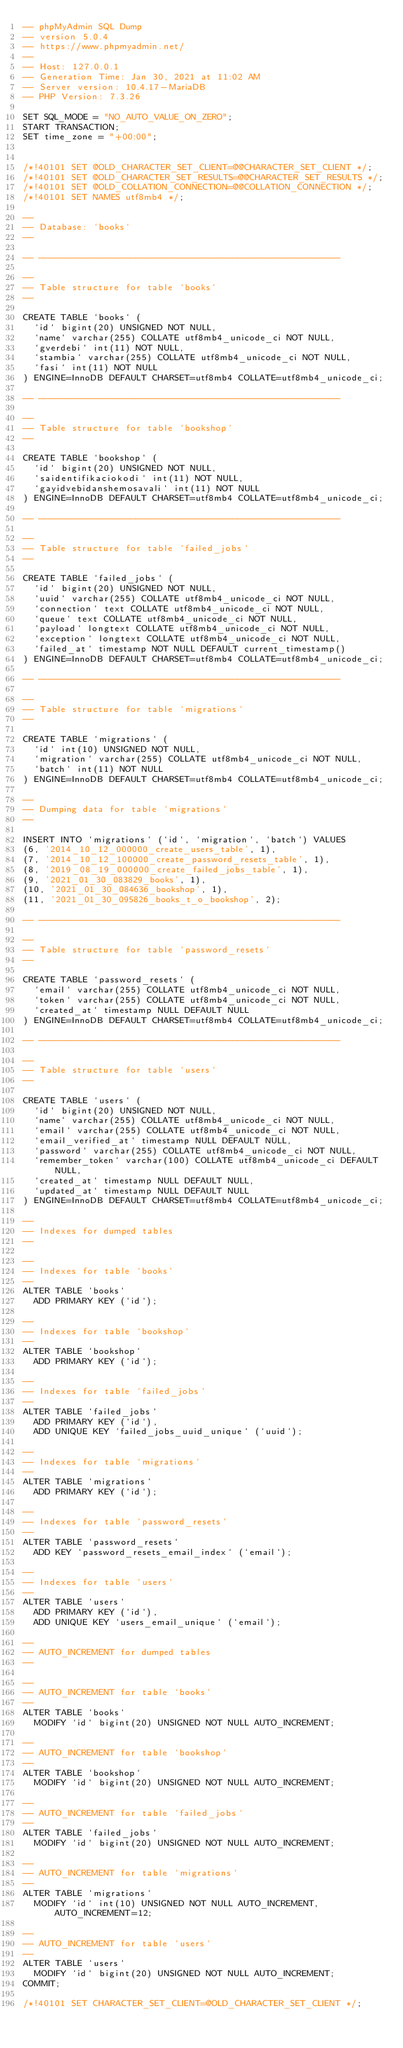Convert code to text. <code><loc_0><loc_0><loc_500><loc_500><_SQL_>-- phpMyAdmin SQL Dump
-- version 5.0.4
-- https://www.phpmyadmin.net/
--
-- Host: 127.0.0.1
-- Generation Time: Jan 30, 2021 at 11:02 AM
-- Server version: 10.4.17-MariaDB
-- PHP Version: 7.3.26

SET SQL_MODE = "NO_AUTO_VALUE_ON_ZERO";
START TRANSACTION;
SET time_zone = "+00:00";


/*!40101 SET @OLD_CHARACTER_SET_CLIENT=@@CHARACTER_SET_CLIENT */;
/*!40101 SET @OLD_CHARACTER_SET_RESULTS=@@CHARACTER_SET_RESULTS */;
/*!40101 SET @OLD_COLLATION_CONNECTION=@@COLLATION_CONNECTION */;
/*!40101 SET NAMES utf8mb4 */;

--
-- Database: `books`
--

-- --------------------------------------------------------

--
-- Table structure for table `books`
--

CREATE TABLE `books` (
  `id` bigint(20) UNSIGNED NOT NULL,
  `name` varchar(255) COLLATE utf8mb4_unicode_ci NOT NULL,
  `gverdebi` int(11) NOT NULL,
  `stambia` varchar(255) COLLATE utf8mb4_unicode_ci NOT NULL,
  `fasi` int(11) NOT NULL
) ENGINE=InnoDB DEFAULT CHARSET=utf8mb4 COLLATE=utf8mb4_unicode_ci;

-- --------------------------------------------------------

--
-- Table structure for table `bookshop`
--

CREATE TABLE `bookshop` (
  `id` bigint(20) UNSIGNED NOT NULL,
  `saidentifikaciokodi` int(11) NOT NULL,
  `gayidvebidanshemosavali` int(11) NOT NULL
) ENGINE=InnoDB DEFAULT CHARSET=utf8mb4 COLLATE=utf8mb4_unicode_ci;

-- --------------------------------------------------------

--
-- Table structure for table `failed_jobs`
--

CREATE TABLE `failed_jobs` (
  `id` bigint(20) UNSIGNED NOT NULL,
  `uuid` varchar(255) COLLATE utf8mb4_unicode_ci NOT NULL,
  `connection` text COLLATE utf8mb4_unicode_ci NOT NULL,
  `queue` text COLLATE utf8mb4_unicode_ci NOT NULL,
  `payload` longtext COLLATE utf8mb4_unicode_ci NOT NULL,
  `exception` longtext COLLATE utf8mb4_unicode_ci NOT NULL,
  `failed_at` timestamp NOT NULL DEFAULT current_timestamp()
) ENGINE=InnoDB DEFAULT CHARSET=utf8mb4 COLLATE=utf8mb4_unicode_ci;

-- --------------------------------------------------------

--
-- Table structure for table `migrations`
--

CREATE TABLE `migrations` (
  `id` int(10) UNSIGNED NOT NULL,
  `migration` varchar(255) COLLATE utf8mb4_unicode_ci NOT NULL,
  `batch` int(11) NOT NULL
) ENGINE=InnoDB DEFAULT CHARSET=utf8mb4 COLLATE=utf8mb4_unicode_ci;

--
-- Dumping data for table `migrations`
--

INSERT INTO `migrations` (`id`, `migration`, `batch`) VALUES
(6, '2014_10_12_000000_create_users_table', 1),
(7, '2014_10_12_100000_create_password_resets_table', 1),
(8, '2019_08_19_000000_create_failed_jobs_table', 1),
(9, '2021_01_30_083829_books', 1),
(10, '2021_01_30_084636_bookshop', 1),
(11, '2021_01_30_095826_books_t_o_bookshop', 2);

-- --------------------------------------------------------

--
-- Table structure for table `password_resets`
--

CREATE TABLE `password_resets` (
  `email` varchar(255) COLLATE utf8mb4_unicode_ci NOT NULL,
  `token` varchar(255) COLLATE utf8mb4_unicode_ci NOT NULL,
  `created_at` timestamp NULL DEFAULT NULL
) ENGINE=InnoDB DEFAULT CHARSET=utf8mb4 COLLATE=utf8mb4_unicode_ci;

-- --------------------------------------------------------

--
-- Table structure for table `users`
--

CREATE TABLE `users` (
  `id` bigint(20) UNSIGNED NOT NULL,
  `name` varchar(255) COLLATE utf8mb4_unicode_ci NOT NULL,
  `email` varchar(255) COLLATE utf8mb4_unicode_ci NOT NULL,
  `email_verified_at` timestamp NULL DEFAULT NULL,
  `password` varchar(255) COLLATE utf8mb4_unicode_ci NOT NULL,
  `remember_token` varchar(100) COLLATE utf8mb4_unicode_ci DEFAULT NULL,
  `created_at` timestamp NULL DEFAULT NULL,
  `updated_at` timestamp NULL DEFAULT NULL
) ENGINE=InnoDB DEFAULT CHARSET=utf8mb4 COLLATE=utf8mb4_unicode_ci;

--
-- Indexes for dumped tables
--

--
-- Indexes for table `books`
--
ALTER TABLE `books`
  ADD PRIMARY KEY (`id`);

--
-- Indexes for table `bookshop`
--
ALTER TABLE `bookshop`
  ADD PRIMARY KEY (`id`);

--
-- Indexes for table `failed_jobs`
--
ALTER TABLE `failed_jobs`
  ADD PRIMARY KEY (`id`),
  ADD UNIQUE KEY `failed_jobs_uuid_unique` (`uuid`);

--
-- Indexes for table `migrations`
--
ALTER TABLE `migrations`
  ADD PRIMARY KEY (`id`);

--
-- Indexes for table `password_resets`
--
ALTER TABLE `password_resets`
  ADD KEY `password_resets_email_index` (`email`);

--
-- Indexes for table `users`
--
ALTER TABLE `users`
  ADD PRIMARY KEY (`id`),
  ADD UNIQUE KEY `users_email_unique` (`email`);

--
-- AUTO_INCREMENT for dumped tables
--

--
-- AUTO_INCREMENT for table `books`
--
ALTER TABLE `books`
  MODIFY `id` bigint(20) UNSIGNED NOT NULL AUTO_INCREMENT;

--
-- AUTO_INCREMENT for table `bookshop`
--
ALTER TABLE `bookshop`
  MODIFY `id` bigint(20) UNSIGNED NOT NULL AUTO_INCREMENT;

--
-- AUTO_INCREMENT for table `failed_jobs`
--
ALTER TABLE `failed_jobs`
  MODIFY `id` bigint(20) UNSIGNED NOT NULL AUTO_INCREMENT;

--
-- AUTO_INCREMENT for table `migrations`
--
ALTER TABLE `migrations`
  MODIFY `id` int(10) UNSIGNED NOT NULL AUTO_INCREMENT, AUTO_INCREMENT=12;

--
-- AUTO_INCREMENT for table `users`
--
ALTER TABLE `users`
  MODIFY `id` bigint(20) UNSIGNED NOT NULL AUTO_INCREMENT;
COMMIT;

/*!40101 SET CHARACTER_SET_CLIENT=@OLD_CHARACTER_SET_CLIENT */;</code> 